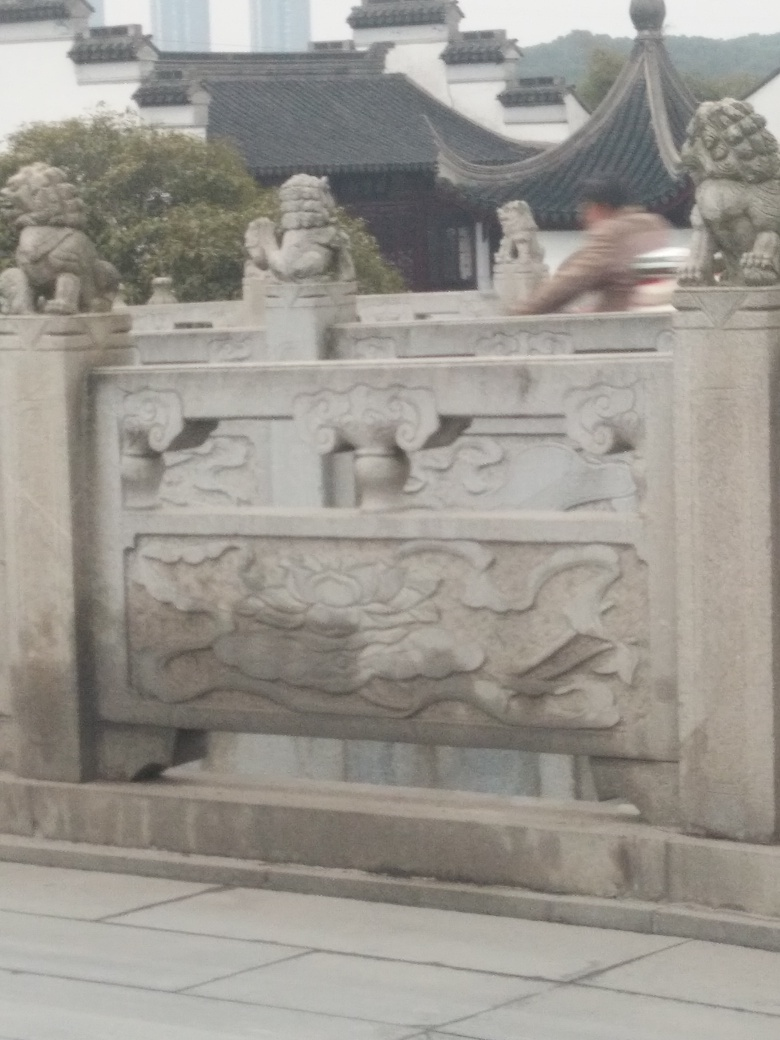Can you describe the artistic style or historical context of the carvings seen on the railing? The carvings on the stone railing are reminiscent of traditional Chinese architectural ornamentation, possibly influenced by styles dating back to the Ming and Qing dynasties. Such designs would typically feature motifs from nature, including flowers and clouds, likely symbolizing harmony and celestial connection in Chinese culture. 